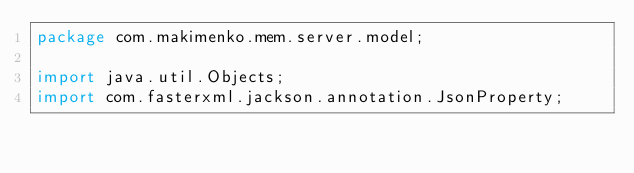<code> <loc_0><loc_0><loc_500><loc_500><_Java_>package com.makimenko.mem.server.model;

import java.util.Objects;
import com.fasterxml.jackson.annotation.JsonProperty;</code> 